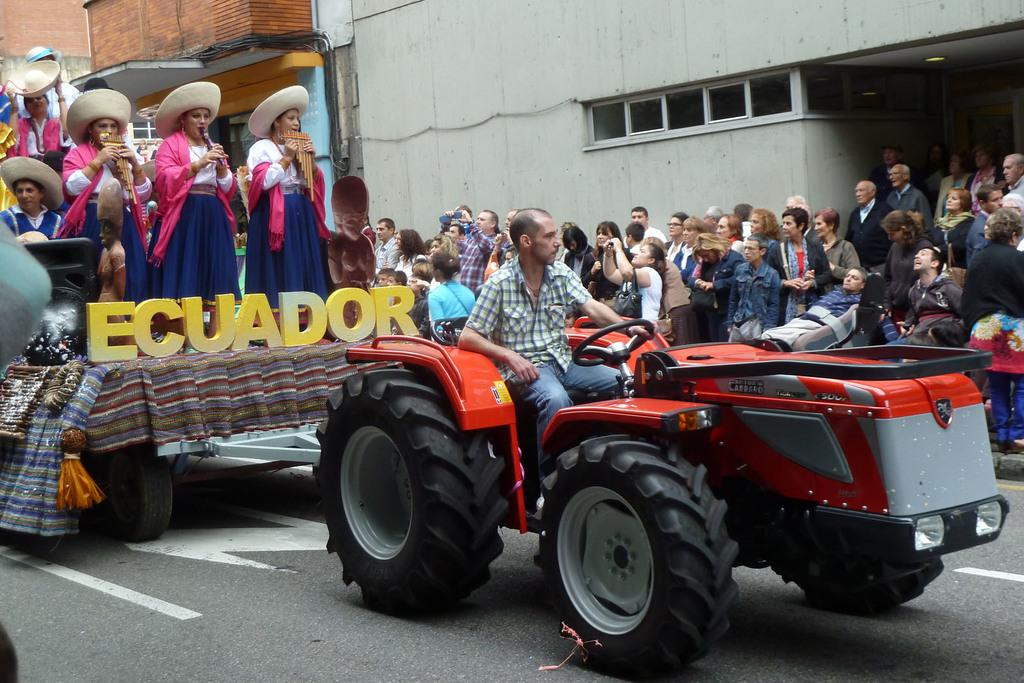What is the main subject of the image? The main subject of the image is a vehicle with persons on it. What type of setting is depicted in the image? The image depicts a road. What can be seen in the background of the image? There is a group of people and buildings visible in the background of the image. Can you see the giraffe walking on the road in the image? There is no giraffe present in the image; it depicts a vehicle with persons on it and a road. 